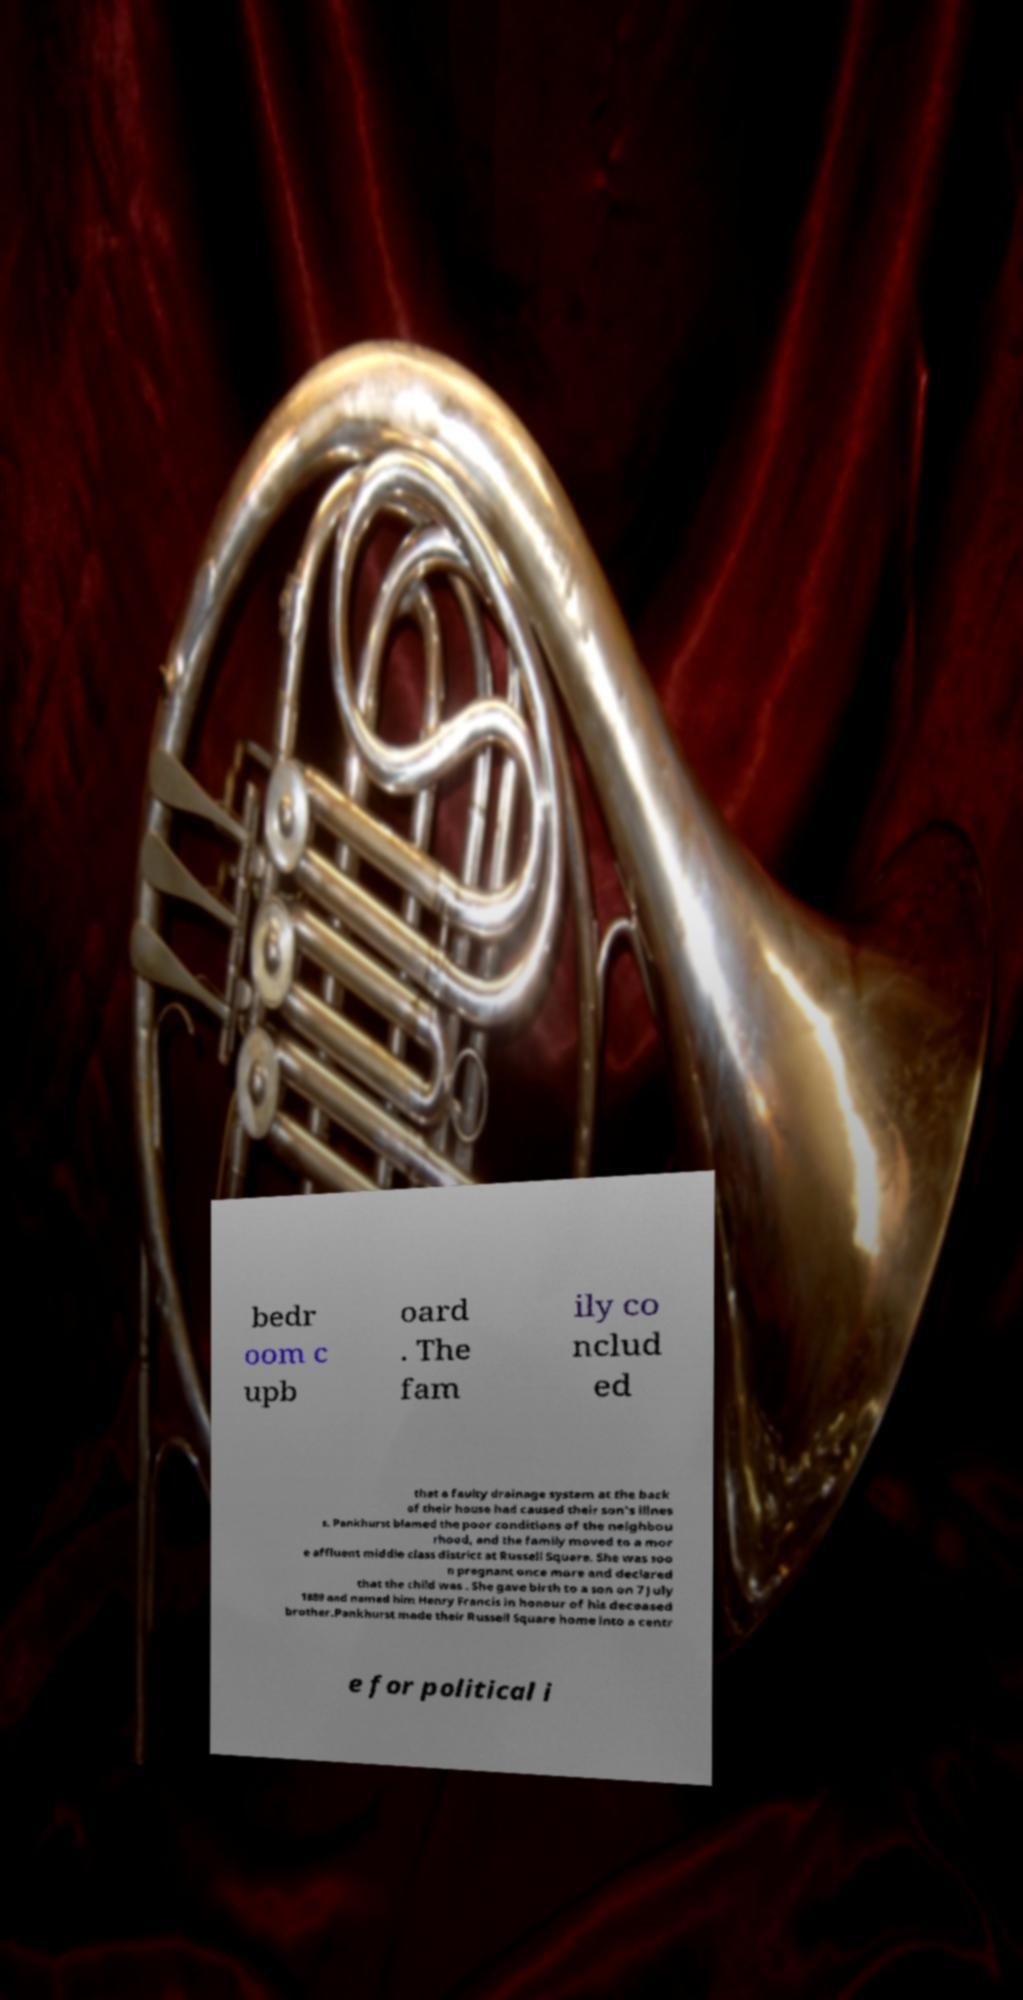I need the written content from this picture converted into text. Can you do that? bedr oom c upb oard . The fam ily co nclud ed that a faulty drainage system at the back of their house had caused their son's illnes s. Pankhurst blamed the poor conditions of the neighbou rhood, and the family moved to a mor e affluent middle class district at Russell Square. She was soo n pregnant once more and declared that the child was . She gave birth to a son on 7 July 1889 and named him Henry Francis in honour of his deceased brother.Pankhurst made their Russell Square home into a centr e for political i 